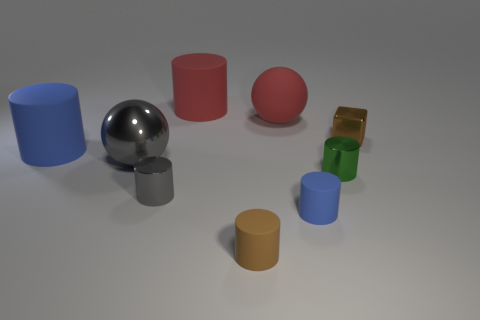Subtract all large red matte cylinders. How many cylinders are left? 5 Subtract all blue spheres. How many blue cylinders are left? 2 Subtract all blocks. How many objects are left? 8 Subtract 5 cylinders. How many cylinders are left? 1 Subtract 0 yellow balls. How many objects are left? 9 Subtract all yellow spheres. Subtract all purple cylinders. How many spheres are left? 2 Subtract all blue balls. Subtract all large matte objects. How many objects are left? 6 Add 9 small shiny blocks. How many small shiny blocks are left? 10 Add 1 large red cylinders. How many large red cylinders exist? 2 Subtract all gray spheres. How many spheres are left? 1 